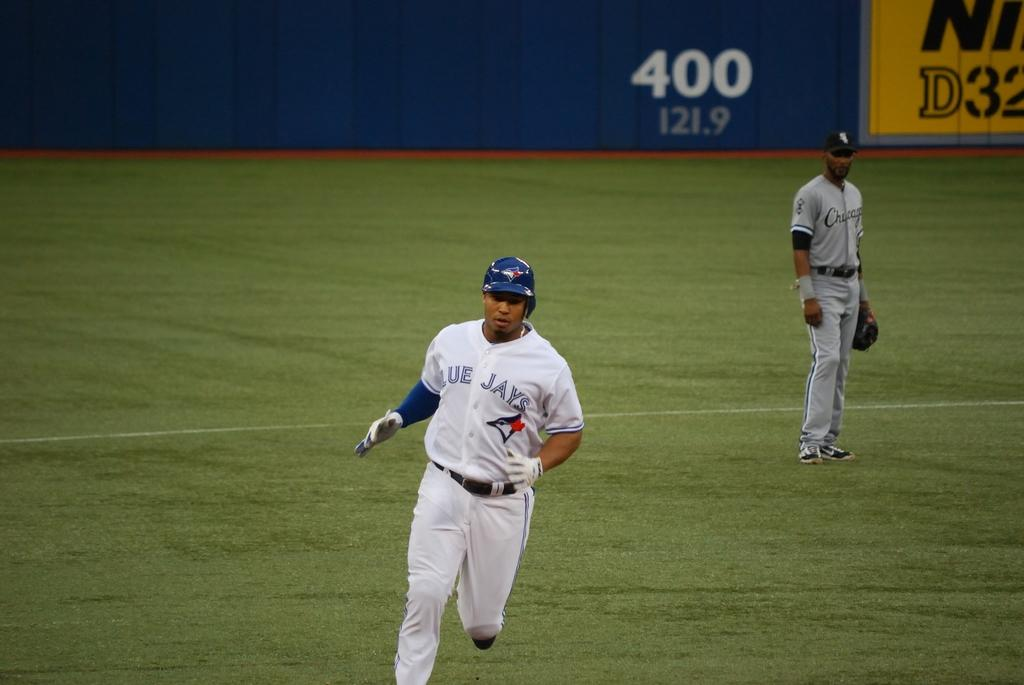<image>
Present a compact description of the photo's key features. A Blue Jays player is seen running in the baseball field with a Chicago player in the background and a 400 on the wall. 